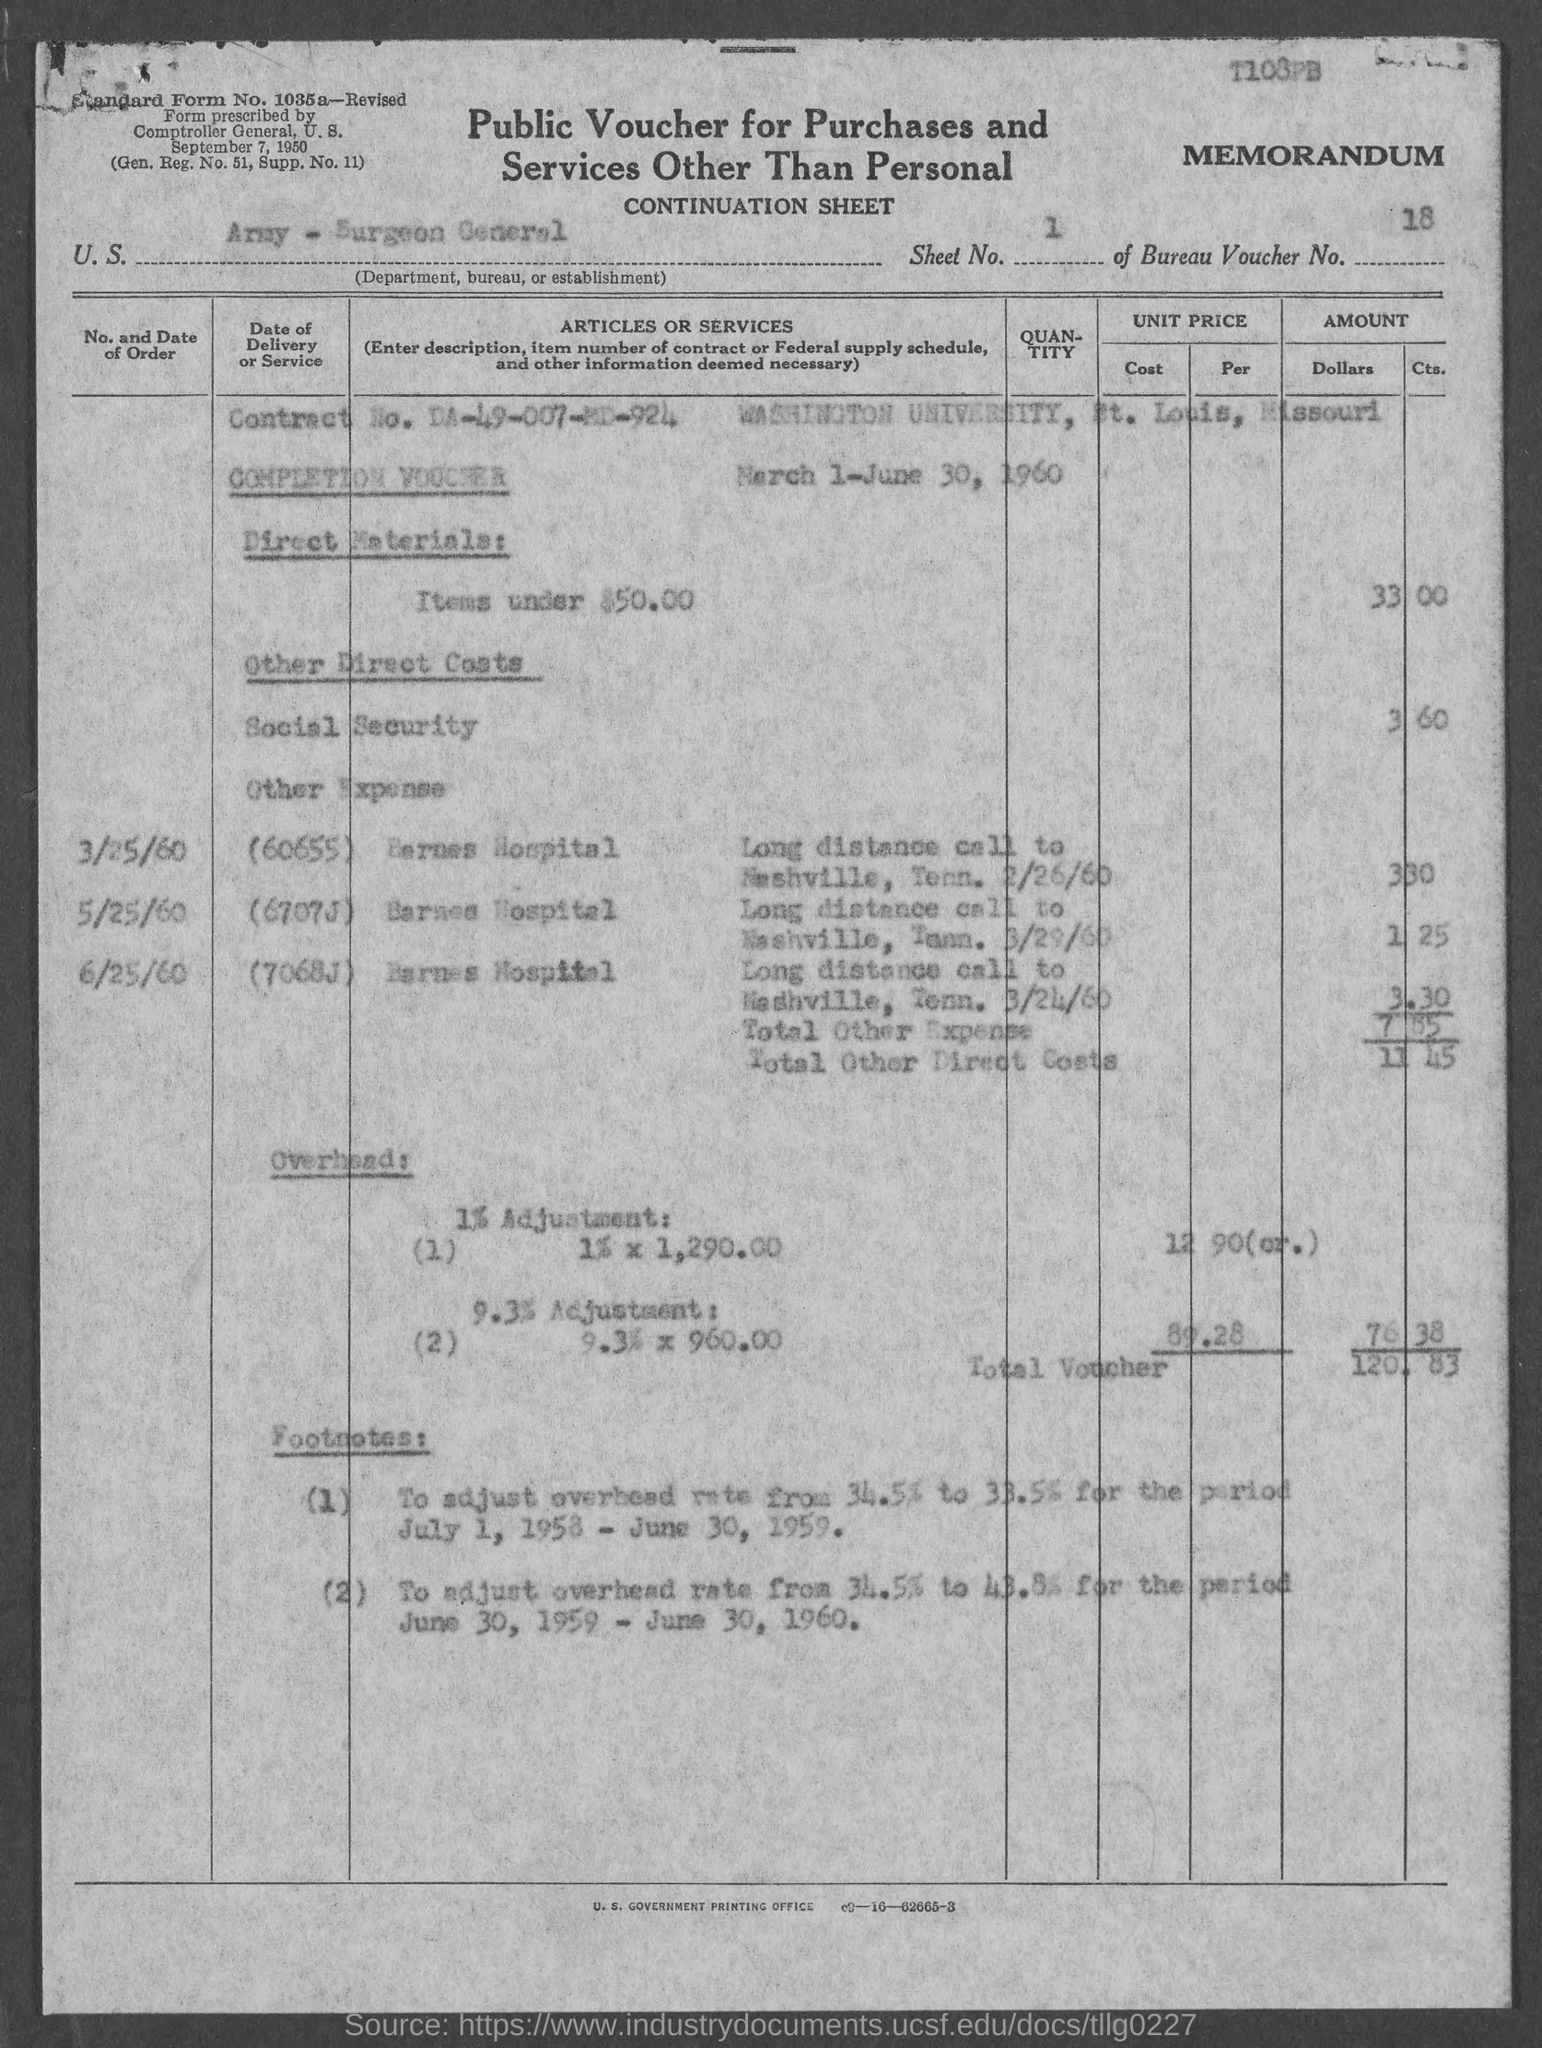Point out several critical features in this image. The sheet number mentioned in the voucher is 1.. The voucher lists the U.S. Department, Bureau, or Establishment as being the Army - Surgeon General. The Bureau Voucher Number mentioned in the document is 18.. The voucher provided is a public one, specifically designed for purchases and services that do not pertain to personal matters. 